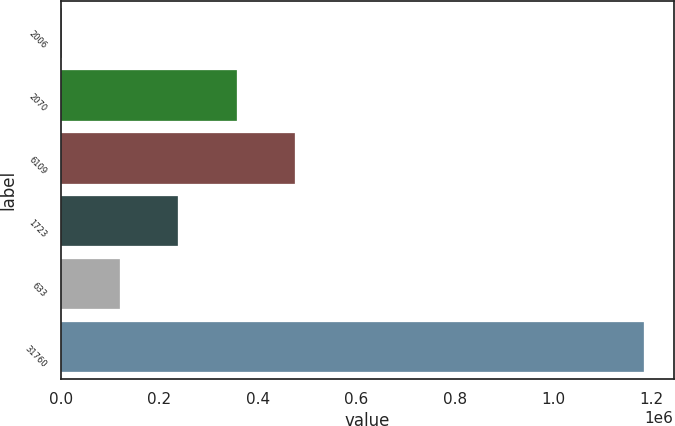Convert chart. <chart><loc_0><loc_0><loc_500><loc_500><bar_chart><fcel>2006<fcel>2070<fcel>6109<fcel>1723<fcel>633<fcel>31760<nl><fcel>2005<fcel>356923<fcel>475229<fcel>238617<fcel>120311<fcel>1.18507e+06<nl></chart> 